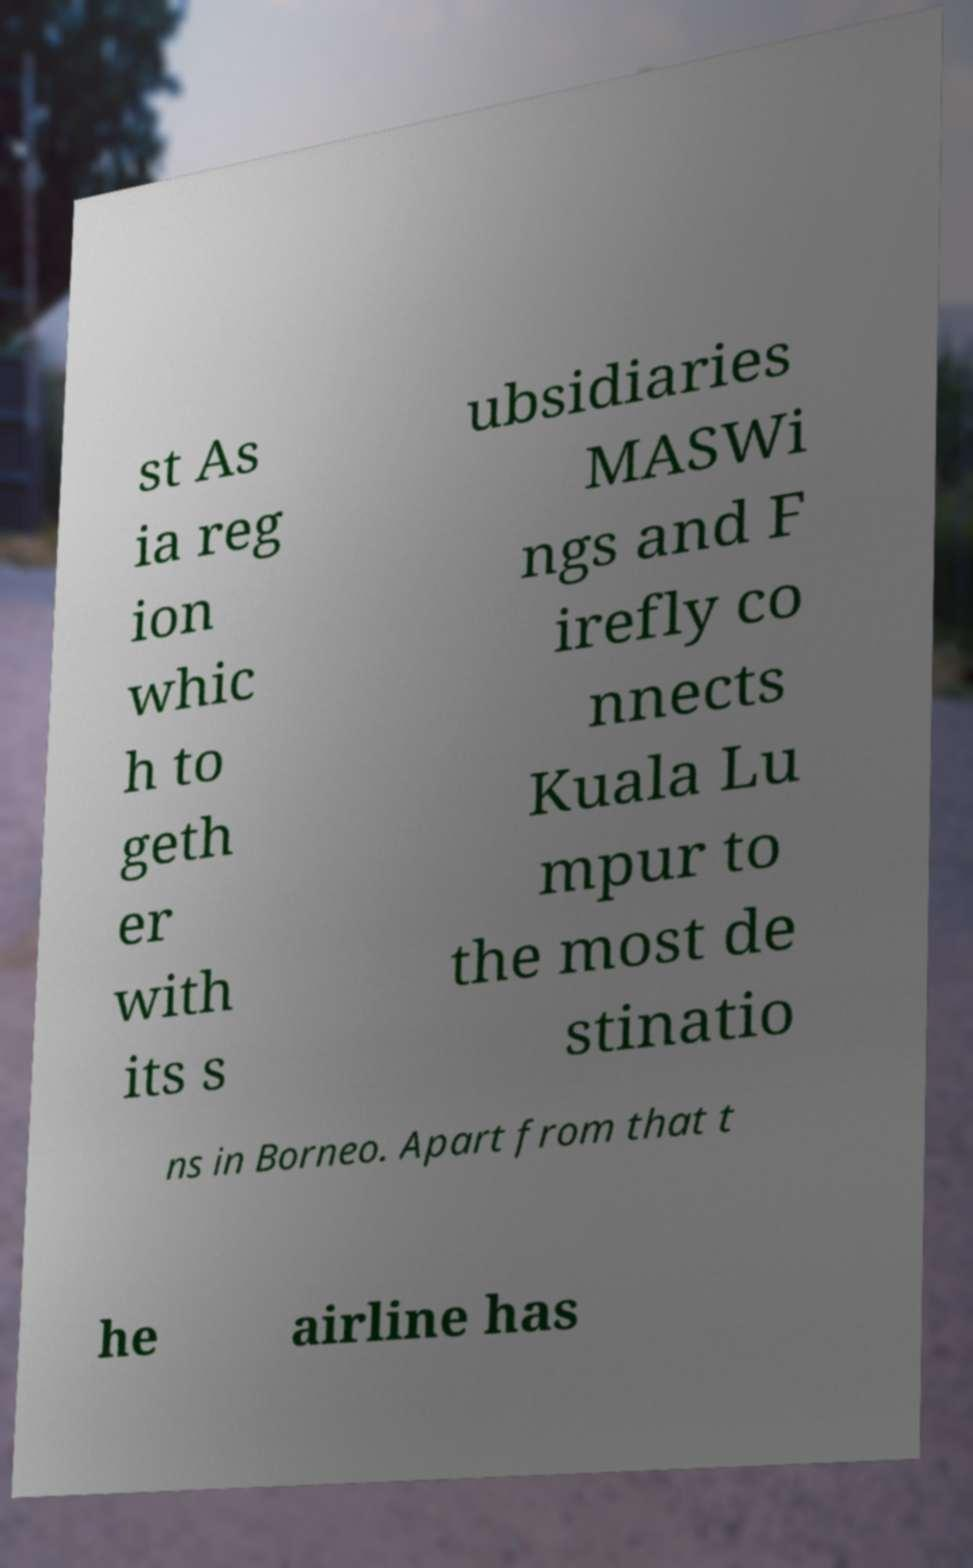Could you extract and type out the text from this image? st As ia reg ion whic h to geth er with its s ubsidiaries MASWi ngs and F irefly co nnects Kuala Lu mpur to the most de stinatio ns in Borneo. Apart from that t he airline has 